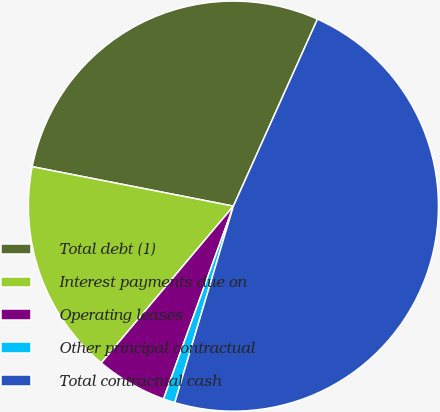Convert chart to OTSL. <chart><loc_0><loc_0><loc_500><loc_500><pie_chart><fcel>Total debt (1)<fcel>Interest payments due on<fcel>Operating leases<fcel>Other principal contractual<fcel>Total contractual cash<nl><fcel>28.64%<fcel>16.94%<fcel>5.61%<fcel>0.92%<fcel>47.89%<nl></chart> 